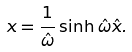<formula> <loc_0><loc_0><loc_500><loc_500>x = \frac { 1 } { \hat { \omega } } \sinh \hat { \omega } \hat { x } .</formula> 